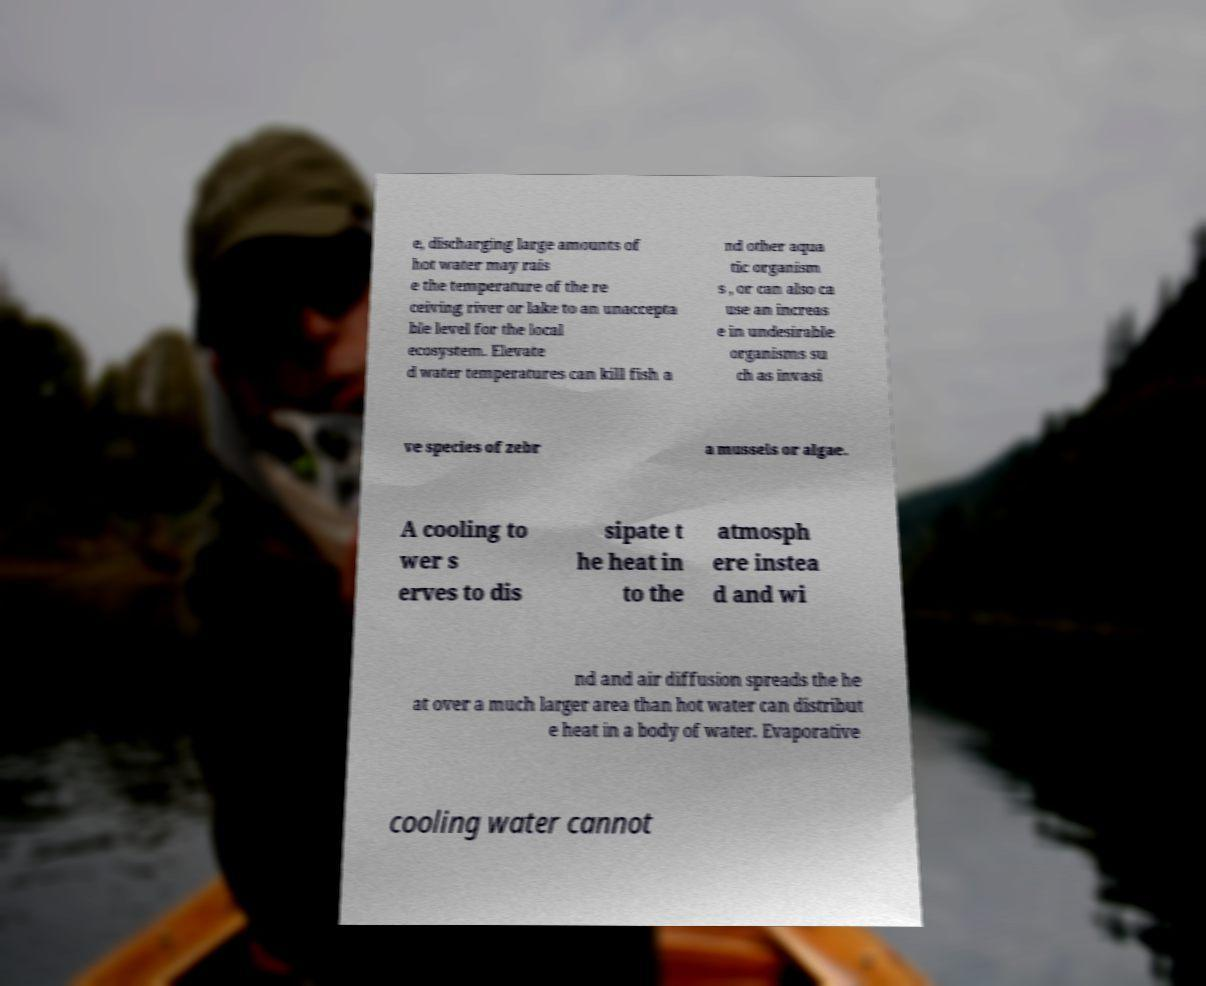I need the written content from this picture converted into text. Can you do that? e, discharging large amounts of hot water may rais e the temperature of the re ceiving river or lake to an unaccepta ble level for the local ecosystem. Elevate d water temperatures can kill fish a nd other aqua tic organism s , or can also ca use an increas e in undesirable organisms su ch as invasi ve species of zebr a mussels or algae. A cooling to wer s erves to dis sipate t he heat in to the atmosph ere instea d and wi nd and air diffusion spreads the he at over a much larger area than hot water can distribut e heat in a body of water. Evaporative cooling water cannot 